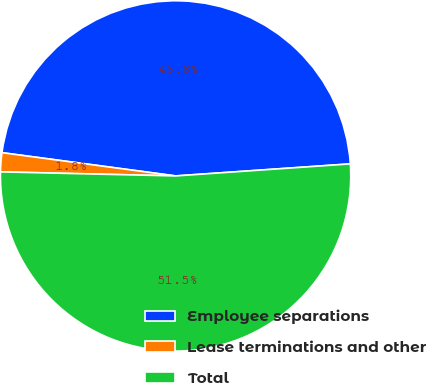Convert chart. <chart><loc_0><loc_0><loc_500><loc_500><pie_chart><fcel>Employee separations<fcel>Lease terminations and other<fcel>Total<nl><fcel>46.78%<fcel>1.75%<fcel>51.46%<nl></chart> 